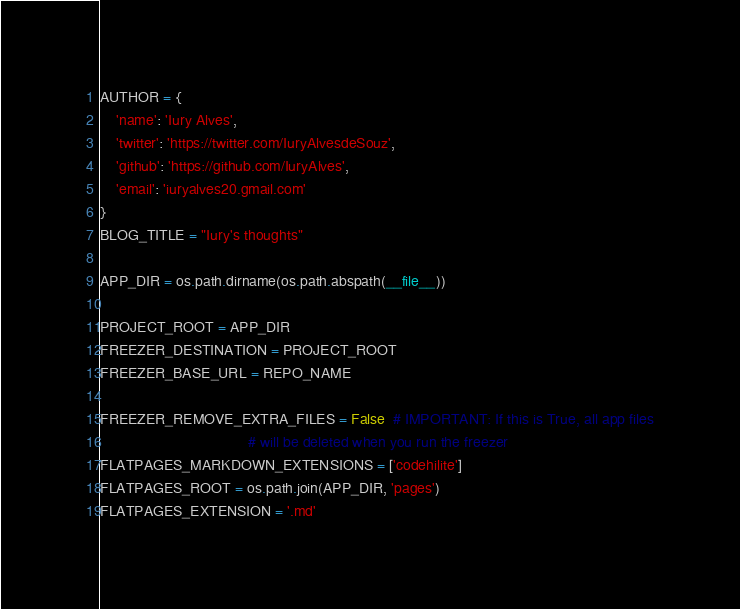<code> <loc_0><loc_0><loc_500><loc_500><_Python_>AUTHOR = {
	'name': 'Iury Alves',
	'twitter': 'https://twitter.com/IuryAlvesdeSouz',
	'github': 'https://github.com/IuryAlves',
	'email': 'iuryalves20.gmail.com'
}
BLOG_TITLE = "Iury's thoughts"

APP_DIR = os.path.dirname(os.path.abspath(__file__))

PROJECT_ROOT = APP_DIR
FREEZER_DESTINATION = PROJECT_ROOT
FREEZER_BASE_URL = REPO_NAME

FREEZER_REMOVE_EXTRA_FILES = False  # IMPORTANT: If this is True, all app files
                                    # will be deleted when you run the freezer
FLATPAGES_MARKDOWN_EXTENSIONS = ['codehilite']
FLATPAGES_ROOT = os.path.join(APP_DIR, 'pages')
FLATPAGES_EXTENSION = '.md'</code> 